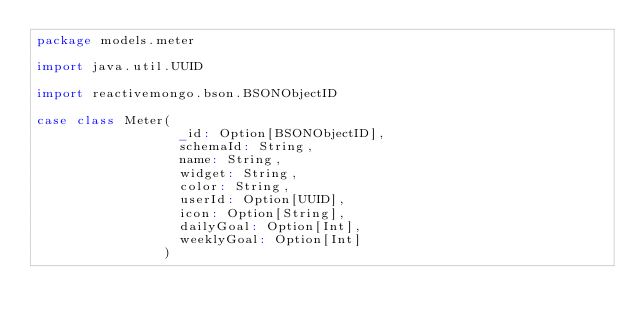<code> <loc_0><loc_0><loc_500><loc_500><_Scala_>package models.meter

import java.util.UUID

import reactivemongo.bson.BSONObjectID

case class Meter(
                  _id: Option[BSONObjectID],
                  schemaId: String,
                  name: String,
                  widget: String,
                  color: String,
                  userId: Option[UUID],
                  icon: Option[String],
                  dailyGoal: Option[Int],
                  weeklyGoal: Option[Int]
                )
</code> 